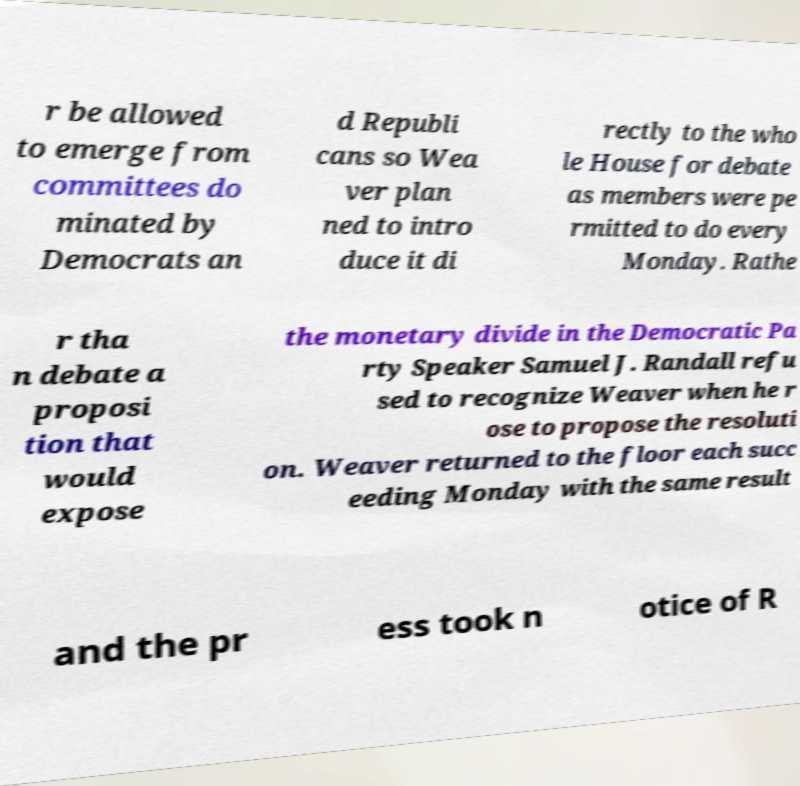For documentation purposes, I need the text within this image transcribed. Could you provide that? r be allowed to emerge from committees do minated by Democrats an d Republi cans so Wea ver plan ned to intro duce it di rectly to the who le House for debate as members were pe rmitted to do every Monday. Rathe r tha n debate a proposi tion that would expose the monetary divide in the Democratic Pa rty Speaker Samuel J. Randall refu sed to recognize Weaver when he r ose to propose the resoluti on. Weaver returned to the floor each succ eeding Monday with the same result and the pr ess took n otice of R 